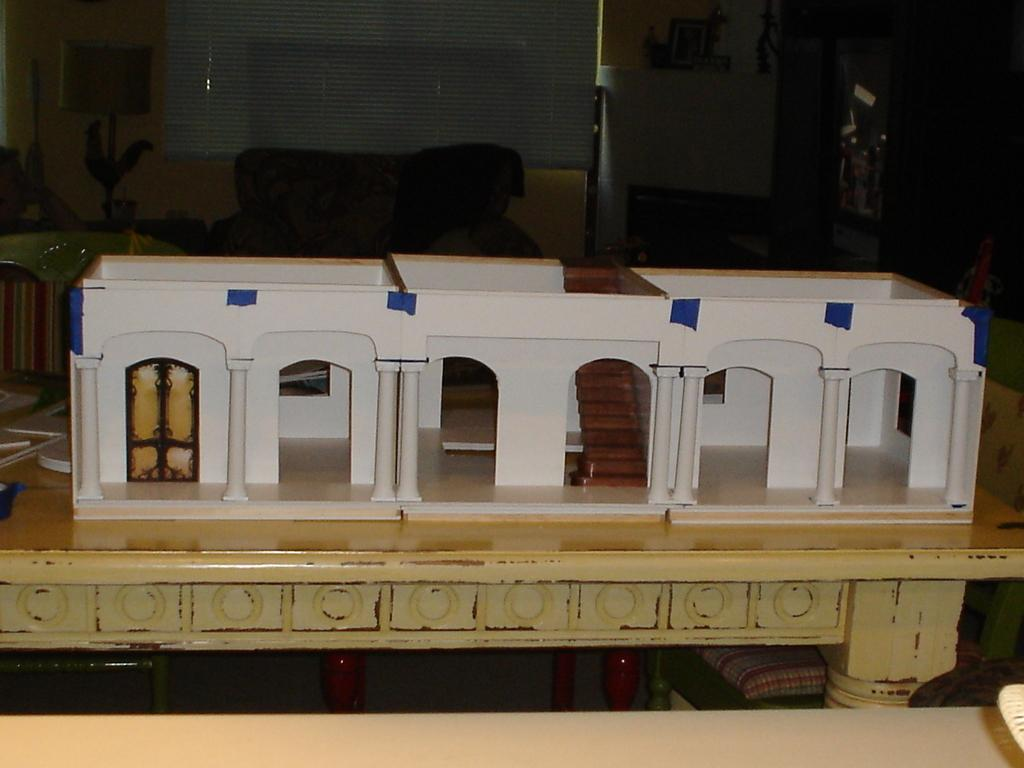What is on the table in the image? There is a design of a building on the table. What furniture is around the table? There are chairs around the table. What can be seen in the background of the image? There is a wall, a frame, a sofa, and a lamp in the background. What type of stew is being cooked on the table in the image? There is no stew present in the image; it features a design of a building on the table. Can you hear the sound of thunder in the image? There is no sound or indication of thunder in the image. 